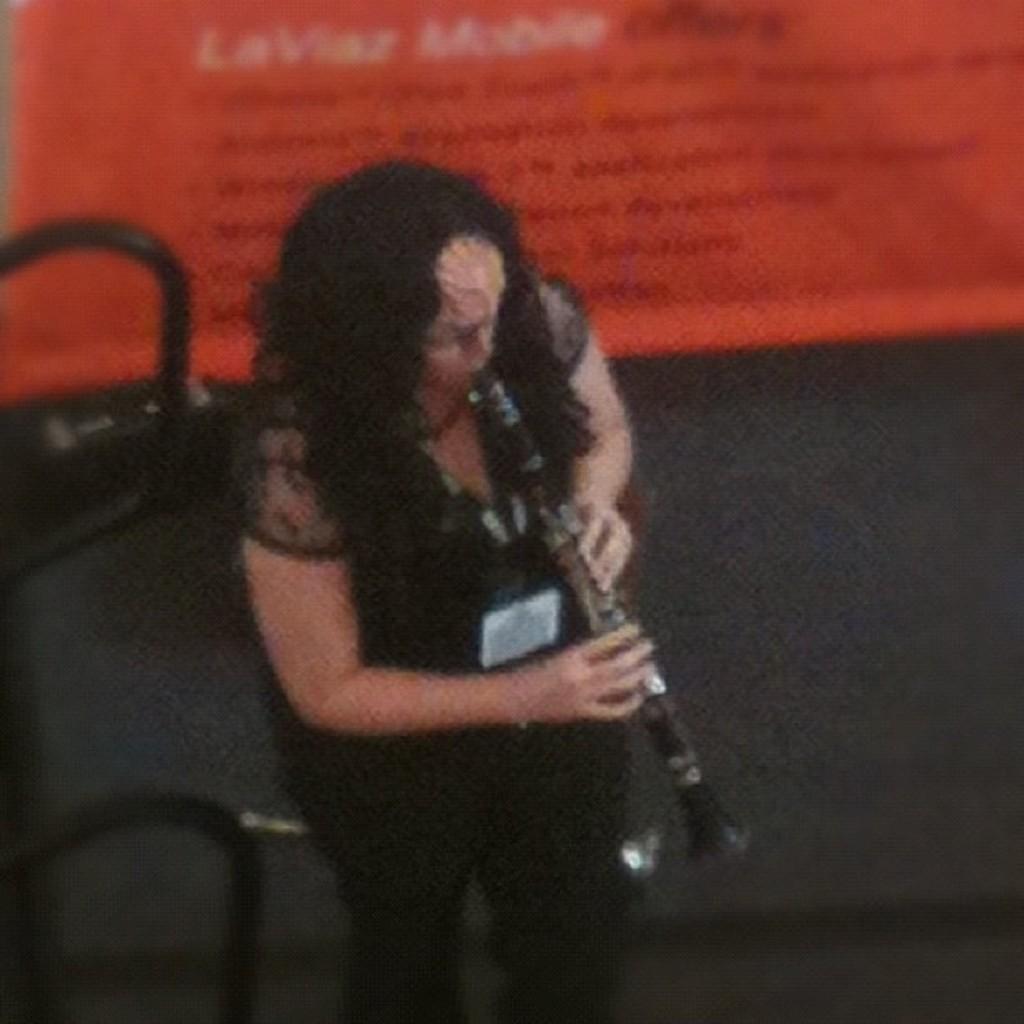In one or two sentences, can you explain what this image depicts? In the picture I can see women wearing black dress is standing and playing trumpet in her hands and there is a banner behind her which has something written on it. 